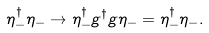Convert formula to latex. <formula><loc_0><loc_0><loc_500><loc_500>\eta ^ { \dagger } _ { - } \eta _ { - } \to \eta ^ { \dagger } _ { - } g ^ { \dagger } g \eta _ { - } = \eta ^ { \dagger } _ { - } \eta _ { - } .</formula> 